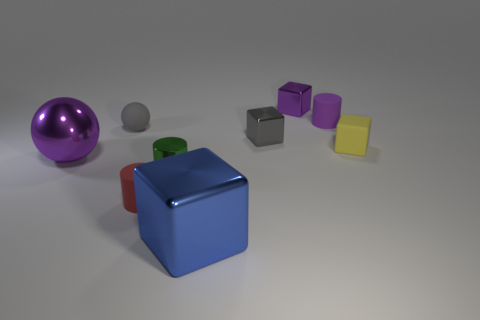Is the size of the yellow rubber block the same as the green thing?
Provide a short and direct response. Yes. What is the tiny gray ball made of?
Provide a succinct answer. Rubber. What material is the cylinder that is the same color as the large metallic ball?
Give a very brief answer. Rubber. There is a large object that is on the left side of the gray matte ball; is it the same shape as the gray matte thing?
Your answer should be very brief. Yes. What number of objects are tiny blue shiny things or matte things?
Your response must be concise. 4. Does the gray object right of the large blue metal object have the same material as the large purple object?
Provide a succinct answer. Yes. What is the size of the yellow rubber thing?
Your answer should be compact. Small. There is a tiny thing that is the same color as the rubber ball; what is its shape?
Give a very brief answer. Cube. What number of blocks are either tiny gray objects or small purple shiny objects?
Ensure brevity in your answer.  2. Are there an equal number of purple cylinders on the right side of the tiny purple rubber cylinder and matte balls that are in front of the small rubber block?
Give a very brief answer. Yes. 